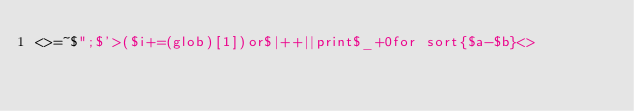Convert code to text. <code><loc_0><loc_0><loc_500><loc_500><_Perl_><>=~$";$'>($i+=(glob)[1])or$|++||print$_+0for sort{$a-$b}<></code> 